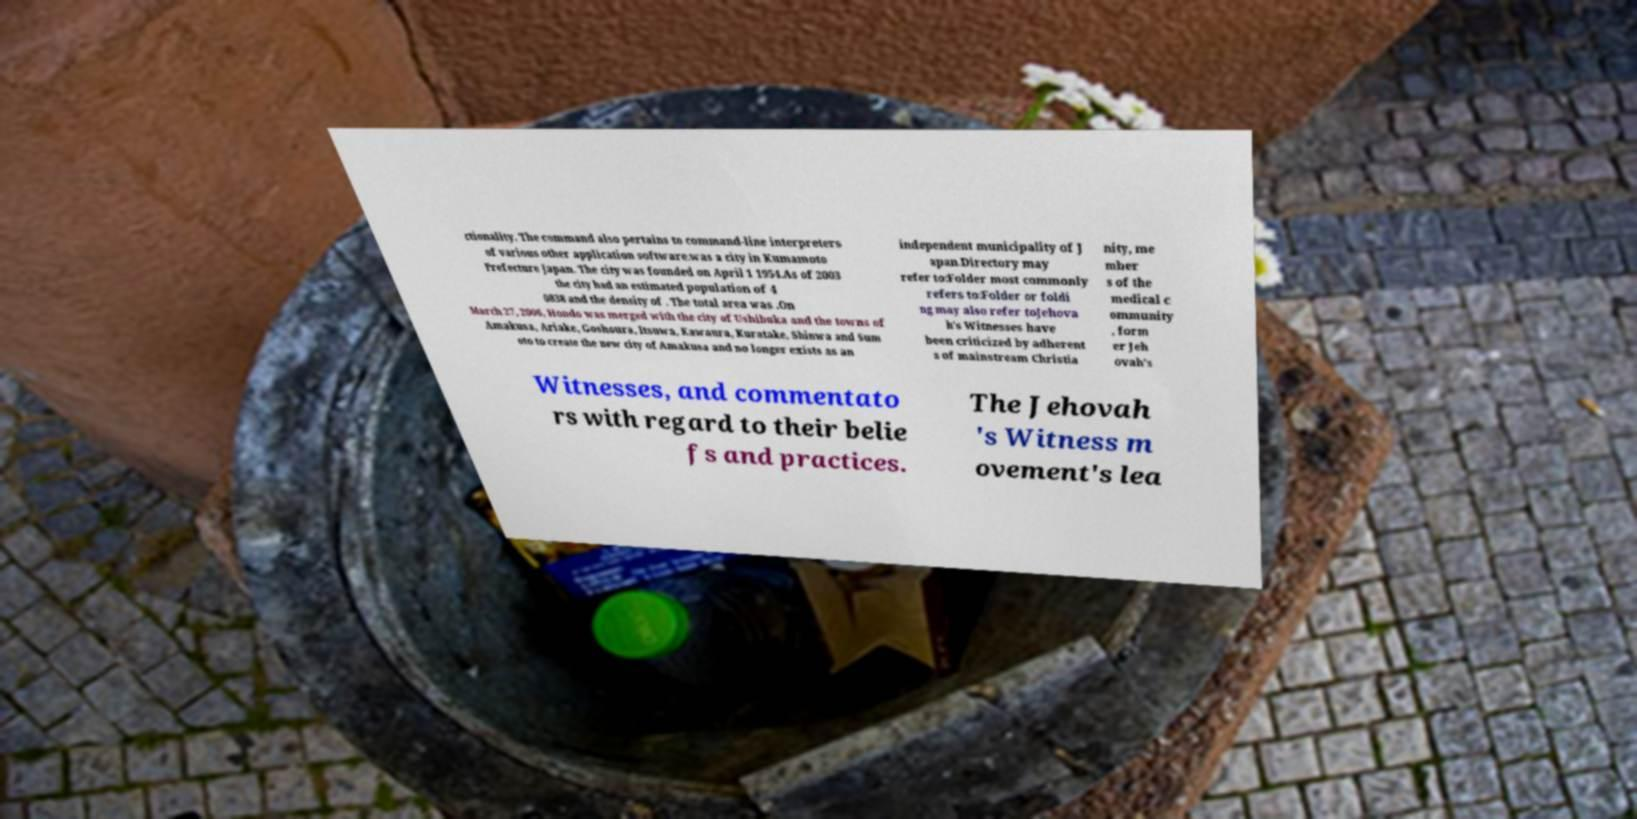There's text embedded in this image that I need extracted. Can you transcribe it verbatim? ctionality. The command also pertains to command-line interpreters of various other application software.was a city in Kumamoto Prefecture Japan. The city was founded on April 1 1954.As of 2003 the city had an estimated population of 4 0838 and the density of . The total area was .On March 27, 2006, Hondo was merged with the city of Ushibuka and the towns of Amakusa, Ariake, Goshoura, Itsuwa, Kawaura, Kuratake, Shinwa and Sum oto to create the new city of Amakusa and no longer exists as an independent municipality of J apan.Directory may refer to:Folder most commonly refers to:Folder or foldi ng may also refer toJehova h's Witnesses have been criticized by adherent s of mainstream Christia nity, me mber s of the medical c ommunity , form er Jeh ovah's Witnesses, and commentato rs with regard to their belie fs and practices. The Jehovah 's Witness m ovement's lea 